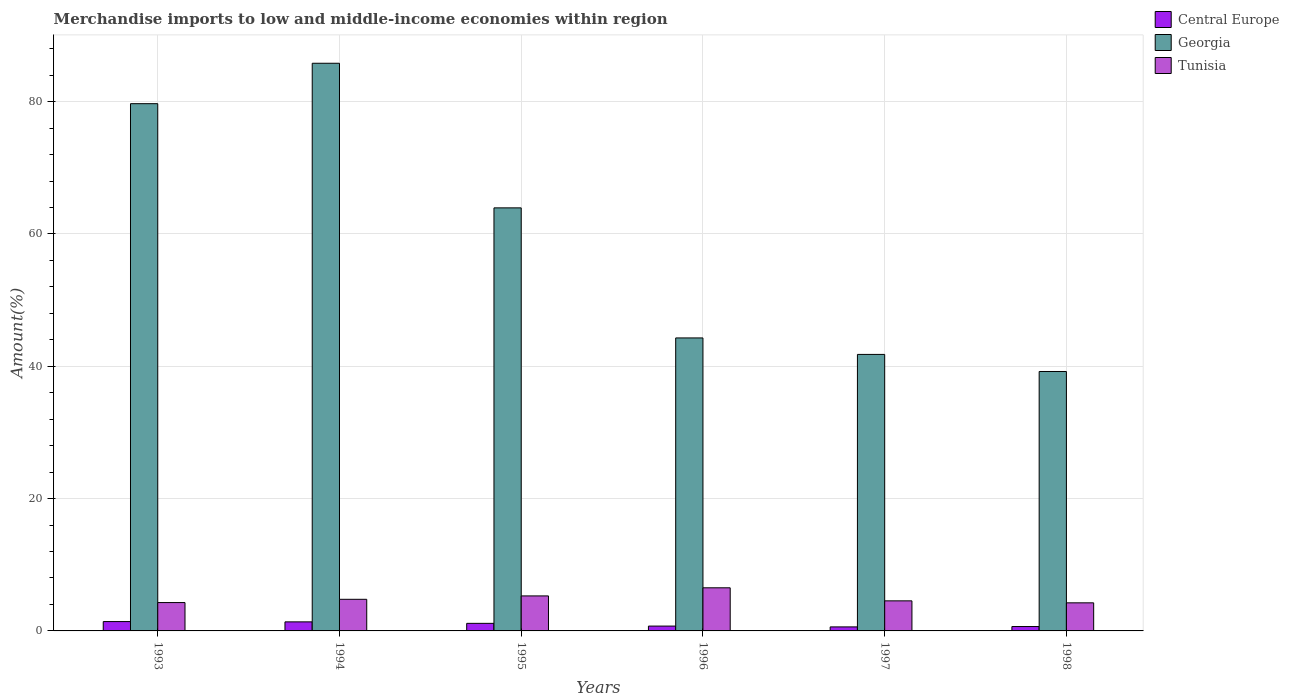Are the number of bars per tick equal to the number of legend labels?
Offer a very short reply. Yes. Are the number of bars on each tick of the X-axis equal?
Provide a succinct answer. Yes. In how many cases, is the number of bars for a given year not equal to the number of legend labels?
Give a very brief answer. 0. What is the percentage of amount earned from merchandise imports in Georgia in 1997?
Offer a very short reply. 41.8. Across all years, what is the maximum percentage of amount earned from merchandise imports in Central Europe?
Make the answer very short. 1.41. Across all years, what is the minimum percentage of amount earned from merchandise imports in Tunisia?
Your answer should be very brief. 4.25. In which year was the percentage of amount earned from merchandise imports in Central Europe minimum?
Keep it short and to the point. 1997. What is the total percentage of amount earned from merchandise imports in Central Europe in the graph?
Keep it short and to the point. 5.92. What is the difference between the percentage of amount earned from merchandise imports in Tunisia in 1996 and that in 1997?
Offer a terse response. 1.97. What is the difference between the percentage of amount earned from merchandise imports in Central Europe in 1994 and the percentage of amount earned from merchandise imports in Tunisia in 1995?
Keep it short and to the point. -3.92. What is the average percentage of amount earned from merchandise imports in Georgia per year?
Offer a terse response. 59.13. In the year 1996, what is the difference between the percentage of amount earned from merchandise imports in Tunisia and percentage of amount earned from merchandise imports in Central Europe?
Provide a short and direct response. 5.79. In how many years, is the percentage of amount earned from merchandise imports in Central Europe greater than 76 %?
Your answer should be very brief. 0. What is the ratio of the percentage of amount earned from merchandise imports in Georgia in 1993 to that in 1998?
Your response must be concise. 2.03. Is the percentage of amount earned from merchandise imports in Central Europe in 1996 less than that in 1997?
Make the answer very short. No. What is the difference between the highest and the second highest percentage of amount earned from merchandise imports in Georgia?
Keep it short and to the point. 6.11. What is the difference between the highest and the lowest percentage of amount earned from merchandise imports in Central Europe?
Offer a terse response. 0.81. In how many years, is the percentage of amount earned from merchandise imports in Tunisia greater than the average percentage of amount earned from merchandise imports in Tunisia taken over all years?
Your answer should be very brief. 2. What does the 2nd bar from the left in 1998 represents?
Provide a short and direct response. Georgia. What does the 2nd bar from the right in 1998 represents?
Offer a terse response. Georgia. How many bars are there?
Your response must be concise. 18. How many years are there in the graph?
Ensure brevity in your answer.  6. Are the values on the major ticks of Y-axis written in scientific E-notation?
Offer a very short reply. No. Does the graph contain any zero values?
Offer a terse response. No. What is the title of the graph?
Your answer should be very brief. Merchandise imports to low and middle-income economies within region. Does "Azerbaijan" appear as one of the legend labels in the graph?
Make the answer very short. No. What is the label or title of the Y-axis?
Offer a very short reply. Amount(%). What is the Amount(%) in Central Europe in 1993?
Offer a terse response. 1.41. What is the Amount(%) of Georgia in 1993?
Your answer should be very brief. 79.7. What is the Amount(%) of Tunisia in 1993?
Offer a terse response. 4.28. What is the Amount(%) of Central Europe in 1994?
Make the answer very short. 1.37. What is the Amount(%) in Georgia in 1994?
Ensure brevity in your answer.  85.81. What is the Amount(%) in Tunisia in 1994?
Provide a short and direct response. 4.78. What is the Amount(%) of Central Europe in 1995?
Give a very brief answer. 1.14. What is the Amount(%) of Georgia in 1995?
Ensure brevity in your answer.  63.95. What is the Amount(%) of Tunisia in 1995?
Make the answer very short. 5.29. What is the Amount(%) in Central Europe in 1996?
Provide a short and direct response. 0.73. What is the Amount(%) of Georgia in 1996?
Offer a terse response. 44.29. What is the Amount(%) of Tunisia in 1996?
Offer a terse response. 6.52. What is the Amount(%) in Central Europe in 1997?
Make the answer very short. 0.61. What is the Amount(%) of Georgia in 1997?
Keep it short and to the point. 41.8. What is the Amount(%) in Tunisia in 1997?
Keep it short and to the point. 4.54. What is the Amount(%) of Central Europe in 1998?
Offer a very short reply. 0.66. What is the Amount(%) in Georgia in 1998?
Give a very brief answer. 39.22. What is the Amount(%) in Tunisia in 1998?
Provide a short and direct response. 4.25. Across all years, what is the maximum Amount(%) in Central Europe?
Provide a succinct answer. 1.41. Across all years, what is the maximum Amount(%) in Georgia?
Ensure brevity in your answer.  85.81. Across all years, what is the maximum Amount(%) in Tunisia?
Your answer should be compact. 6.52. Across all years, what is the minimum Amount(%) in Central Europe?
Offer a terse response. 0.61. Across all years, what is the minimum Amount(%) in Georgia?
Your answer should be very brief. 39.22. Across all years, what is the minimum Amount(%) in Tunisia?
Provide a short and direct response. 4.25. What is the total Amount(%) of Central Europe in the graph?
Keep it short and to the point. 5.92. What is the total Amount(%) in Georgia in the graph?
Give a very brief answer. 354.75. What is the total Amount(%) in Tunisia in the graph?
Your response must be concise. 29.66. What is the difference between the Amount(%) in Central Europe in 1993 and that in 1994?
Offer a very short reply. 0.04. What is the difference between the Amount(%) of Georgia in 1993 and that in 1994?
Provide a succinct answer. -6.11. What is the difference between the Amount(%) in Tunisia in 1993 and that in 1994?
Offer a terse response. -0.49. What is the difference between the Amount(%) of Central Europe in 1993 and that in 1995?
Provide a short and direct response. 0.27. What is the difference between the Amount(%) of Georgia in 1993 and that in 1995?
Offer a very short reply. 15.75. What is the difference between the Amount(%) of Tunisia in 1993 and that in 1995?
Ensure brevity in your answer.  -1.01. What is the difference between the Amount(%) in Central Europe in 1993 and that in 1996?
Your answer should be compact. 0.68. What is the difference between the Amount(%) in Georgia in 1993 and that in 1996?
Make the answer very short. 35.41. What is the difference between the Amount(%) of Tunisia in 1993 and that in 1996?
Make the answer very short. -2.23. What is the difference between the Amount(%) in Central Europe in 1993 and that in 1997?
Provide a succinct answer. 0.81. What is the difference between the Amount(%) in Georgia in 1993 and that in 1997?
Provide a short and direct response. 37.9. What is the difference between the Amount(%) of Tunisia in 1993 and that in 1997?
Give a very brief answer. -0.26. What is the difference between the Amount(%) of Central Europe in 1993 and that in 1998?
Provide a succinct answer. 0.75. What is the difference between the Amount(%) of Georgia in 1993 and that in 1998?
Your answer should be compact. 40.48. What is the difference between the Amount(%) of Tunisia in 1993 and that in 1998?
Ensure brevity in your answer.  0.04. What is the difference between the Amount(%) of Central Europe in 1994 and that in 1995?
Give a very brief answer. 0.22. What is the difference between the Amount(%) in Georgia in 1994 and that in 1995?
Provide a short and direct response. 21.86. What is the difference between the Amount(%) of Tunisia in 1994 and that in 1995?
Your answer should be compact. -0.51. What is the difference between the Amount(%) in Central Europe in 1994 and that in 1996?
Offer a terse response. 0.64. What is the difference between the Amount(%) of Georgia in 1994 and that in 1996?
Ensure brevity in your answer.  41.52. What is the difference between the Amount(%) in Tunisia in 1994 and that in 1996?
Offer a terse response. -1.74. What is the difference between the Amount(%) of Central Europe in 1994 and that in 1997?
Make the answer very short. 0.76. What is the difference between the Amount(%) of Georgia in 1994 and that in 1997?
Offer a very short reply. 44.01. What is the difference between the Amount(%) of Tunisia in 1994 and that in 1997?
Offer a very short reply. 0.23. What is the difference between the Amount(%) of Central Europe in 1994 and that in 1998?
Provide a short and direct response. 0.71. What is the difference between the Amount(%) of Georgia in 1994 and that in 1998?
Offer a very short reply. 46.59. What is the difference between the Amount(%) in Tunisia in 1994 and that in 1998?
Make the answer very short. 0.53. What is the difference between the Amount(%) of Central Europe in 1995 and that in 1996?
Give a very brief answer. 0.41. What is the difference between the Amount(%) of Georgia in 1995 and that in 1996?
Your response must be concise. 19.66. What is the difference between the Amount(%) in Tunisia in 1995 and that in 1996?
Give a very brief answer. -1.23. What is the difference between the Amount(%) in Central Europe in 1995 and that in 1997?
Give a very brief answer. 0.54. What is the difference between the Amount(%) of Georgia in 1995 and that in 1997?
Provide a succinct answer. 22.15. What is the difference between the Amount(%) in Tunisia in 1995 and that in 1997?
Offer a very short reply. 0.75. What is the difference between the Amount(%) in Central Europe in 1995 and that in 1998?
Offer a very short reply. 0.48. What is the difference between the Amount(%) in Georgia in 1995 and that in 1998?
Provide a short and direct response. 24.73. What is the difference between the Amount(%) in Tunisia in 1995 and that in 1998?
Make the answer very short. 1.05. What is the difference between the Amount(%) in Central Europe in 1996 and that in 1997?
Offer a terse response. 0.12. What is the difference between the Amount(%) of Georgia in 1996 and that in 1997?
Offer a terse response. 2.49. What is the difference between the Amount(%) of Tunisia in 1996 and that in 1997?
Give a very brief answer. 1.97. What is the difference between the Amount(%) of Central Europe in 1996 and that in 1998?
Provide a short and direct response. 0.07. What is the difference between the Amount(%) in Georgia in 1996 and that in 1998?
Keep it short and to the point. 5.07. What is the difference between the Amount(%) of Tunisia in 1996 and that in 1998?
Your response must be concise. 2.27. What is the difference between the Amount(%) of Central Europe in 1997 and that in 1998?
Offer a very short reply. -0.05. What is the difference between the Amount(%) of Georgia in 1997 and that in 1998?
Provide a succinct answer. 2.58. What is the difference between the Amount(%) of Tunisia in 1997 and that in 1998?
Give a very brief answer. 0.3. What is the difference between the Amount(%) of Central Europe in 1993 and the Amount(%) of Georgia in 1994?
Make the answer very short. -84.39. What is the difference between the Amount(%) in Central Europe in 1993 and the Amount(%) in Tunisia in 1994?
Offer a terse response. -3.37. What is the difference between the Amount(%) of Georgia in 1993 and the Amount(%) of Tunisia in 1994?
Provide a short and direct response. 74.92. What is the difference between the Amount(%) of Central Europe in 1993 and the Amount(%) of Georgia in 1995?
Offer a very short reply. -62.54. What is the difference between the Amount(%) of Central Europe in 1993 and the Amount(%) of Tunisia in 1995?
Keep it short and to the point. -3.88. What is the difference between the Amount(%) of Georgia in 1993 and the Amount(%) of Tunisia in 1995?
Provide a short and direct response. 74.41. What is the difference between the Amount(%) in Central Europe in 1993 and the Amount(%) in Georgia in 1996?
Give a very brief answer. -42.88. What is the difference between the Amount(%) in Central Europe in 1993 and the Amount(%) in Tunisia in 1996?
Your answer should be compact. -5.11. What is the difference between the Amount(%) of Georgia in 1993 and the Amount(%) of Tunisia in 1996?
Offer a terse response. 73.18. What is the difference between the Amount(%) in Central Europe in 1993 and the Amount(%) in Georgia in 1997?
Keep it short and to the point. -40.38. What is the difference between the Amount(%) of Central Europe in 1993 and the Amount(%) of Tunisia in 1997?
Offer a very short reply. -3.13. What is the difference between the Amount(%) of Georgia in 1993 and the Amount(%) of Tunisia in 1997?
Make the answer very short. 75.15. What is the difference between the Amount(%) of Central Europe in 1993 and the Amount(%) of Georgia in 1998?
Provide a succinct answer. -37.8. What is the difference between the Amount(%) in Central Europe in 1993 and the Amount(%) in Tunisia in 1998?
Offer a terse response. -2.83. What is the difference between the Amount(%) of Georgia in 1993 and the Amount(%) of Tunisia in 1998?
Give a very brief answer. 75.45. What is the difference between the Amount(%) in Central Europe in 1994 and the Amount(%) in Georgia in 1995?
Offer a terse response. -62.58. What is the difference between the Amount(%) of Central Europe in 1994 and the Amount(%) of Tunisia in 1995?
Provide a succinct answer. -3.92. What is the difference between the Amount(%) in Georgia in 1994 and the Amount(%) in Tunisia in 1995?
Provide a succinct answer. 80.52. What is the difference between the Amount(%) of Central Europe in 1994 and the Amount(%) of Georgia in 1996?
Your answer should be compact. -42.92. What is the difference between the Amount(%) in Central Europe in 1994 and the Amount(%) in Tunisia in 1996?
Offer a very short reply. -5.15. What is the difference between the Amount(%) of Georgia in 1994 and the Amount(%) of Tunisia in 1996?
Offer a terse response. 79.29. What is the difference between the Amount(%) of Central Europe in 1994 and the Amount(%) of Georgia in 1997?
Your answer should be compact. -40.43. What is the difference between the Amount(%) in Central Europe in 1994 and the Amount(%) in Tunisia in 1997?
Provide a short and direct response. -3.18. What is the difference between the Amount(%) of Georgia in 1994 and the Amount(%) of Tunisia in 1997?
Offer a very short reply. 81.26. What is the difference between the Amount(%) of Central Europe in 1994 and the Amount(%) of Georgia in 1998?
Your response must be concise. -37.85. What is the difference between the Amount(%) of Central Europe in 1994 and the Amount(%) of Tunisia in 1998?
Provide a succinct answer. -2.88. What is the difference between the Amount(%) of Georgia in 1994 and the Amount(%) of Tunisia in 1998?
Provide a short and direct response. 81.56. What is the difference between the Amount(%) of Central Europe in 1995 and the Amount(%) of Georgia in 1996?
Your answer should be compact. -43.14. What is the difference between the Amount(%) in Central Europe in 1995 and the Amount(%) in Tunisia in 1996?
Your answer should be very brief. -5.37. What is the difference between the Amount(%) in Georgia in 1995 and the Amount(%) in Tunisia in 1996?
Your answer should be compact. 57.43. What is the difference between the Amount(%) of Central Europe in 1995 and the Amount(%) of Georgia in 1997?
Your response must be concise. -40.65. What is the difference between the Amount(%) of Central Europe in 1995 and the Amount(%) of Tunisia in 1997?
Make the answer very short. -3.4. What is the difference between the Amount(%) of Georgia in 1995 and the Amount(%) of Tunisia in 1997?
Provide a short and direct response. 59.41. What is the difference between the Amount(%) of Central Europe in 1995 and the Amount(%) of Georgia in 1998?
Provide a short and direct response. -38.07. What is the difference between the Amount(%) in Central Europe in 1995 and the Amount(%) in Tunisia in 1998?
Offer a very short reply. -3.1. What is the difference between the Amount(%) of Georgia in 1995 and the Amount(%) of Tunisia in 1998?
Provide a succinct answer. 59.7. What is the difference between the Amount(%) of Central Europe in 1996 and the Amount(%) of Georgia in 1997?
Keep it short and to the point. -41.07. What is the difference between the Amount(%) in Central Europe in 1996 and the Amount(%) in Tunisia in 1997?
Provide a short and direct response. -3.81. What is the difference between the Amount(%) in Georgia in 1996 and the Amount(%) in Tunisia in 1997?
Offer a terse response. 39.74. What is the difference between the Amount(%) of Central Europe in 1996 and the Amount(%) of Georgia in 1998?
Provide a short and direct response. -38.49. What is the difference between the Amount(%) in Central Europe in 1996 and the Amount(%) in Tunisia in 1998?
Your answer should be compact. -3.52. What is the difference between the Amount(%) in Georgia in 1996 and the Amount(%) in Tunisia in 1998?
Your answer should be compact. 40.04. What is the difference between the Amount(%) of Central Europe in 1997 and the Amount(%) of Georgia in 1998?
Offer a terse response. -38.61. What is the difference between the Amount(%) in Central Europe in 1997 and the Amount(%) in Tunisia in 1998?
Provide a short and direct response. -3.64. What is the difference between the Amount(%) in Georgia in 1997 and the Amount(%) in Tunisia in 1998?
Give a very brief answer. 37.55. What is the average Amount(%) in Central Europe per year?
Offer a very short reply. 0.99. What is the average Amount(%) in Georgia per year?
Ensure brevity in your answer.  59.13. What is the average Amount(%) in Tunisia per year?
Ensure brevity in your answer.  4.94. In the year 1993, what is the difference between the Amount(%) in Central Europe and Amount(%) in Georgia?
Your answer should be compact. -78.29. In the year 1993, what is the difference between the Amount(%) in Central Europe and Amount(%) in Tunisia?
Offer a very short reply. -2.87. In the year 1993, what is the difference between the Amount(%) in Georgia and Amount(%) in Tunisia?
Ensure brevity in your answer.  75.41. In the year 1994, what is the difference between the Amount(%) of Central Europe and Amount(%) of Georgia?
Provide a succinct answer. -84.44. In the year 1994, what is the difference between the Amount(%) in Central Europe and Amount(%) in Tunisia?
Provide a succinct answer. -3.41. In the year 1994, what is the difference between the Amount(%) of Georgia and Amount(%) of Tunisia?
Your answer should be very brief. 81.03. In the year 1995, what is the difference between the Amount(%) in Central Europe and Amount(%) in Georgia?
Your answer should be compact. -62.81. In the year 1995, what is the difference between the Amount(%) in Central Europe and Amount(%) in Tunisia?
Provide a succinct answer. -4.15. In the year 1995, what is the difference between the Amount(%) in Georgia and Amount(%) in Tunisia?
Make the answer very short. 58.66. In the year 1996, what is the difference between the Amount(%) of Central Europe and Amount(%) of Georgia?
Your response must be concise. -43.56. In the year 1996, what is the difference between the Amount(%) in Central Europe and Amount(%) in Tunisia?
Ensure brevity in your answer.  -5.79. In the year 1996, what is the difference between the Amount(%) in Georgia and Amount(%) in Tunisia?
Make the answer very short. 37.77. In the year 1997, what is the difference between the Amount(%) of Central Europe and Amount(%) of Georgia?
Your response must be concise. -41.19. In the year 1997, what is the difference between the Amount(%) of Central Europe and Amount(%) of Tunisia?
Keep it short and to the point. -3.94. In the year 1997, what is the difference between the Amount(%) in Georgia and Amount(%) in Tunisia?
Provide a succinct answer. 37.25. In the year 1998, what is the difference between the Amount(%) of Central Europe and Amount(%) of Georgia?
Provide a succinct answer. -38.55. In the year 1998, what is the difference between the Amount(%) of Central Europe and Amount(%) of Tunisia?
Ensure brevity in your answer.  -3.58. In the year 1998, what is the difference between the Amount(%) in Georgia and Amount(%) in Tunisia?
Offer a very short reply. 34.97. What is the ratio of the Amount(%) in Central Europe in 1993 to that in 1994?
Provide a succinct answer. 1.03. What is the ratio of the Amount(%) of Georgia in 1993 to that in 1994?
Your answer should be very brief. 0.93. What is the ratio of the Amount(%) in Tunisia in 1993 to that in 1994?
Provide a succinct answer. 0.9. What is the ratio of the Amount(%) in Central Europe in 1993 to that in 1995?
Your response must be concise. 1.24. What is the ratio of the Amount(%) in Georgia in 1993 to that in 1995?
Provide a short and direct response. 1.25. What is the ratio of the Amount(%) of Tunisia in 1993 to that in 1995?
Keep it short and to the point. 0.81. What is the ratio of the Amount(%) of Central Europe in 1993 to that in 1996?
Give a very brief answer. 1.93. What is the ratio of the Amount(%) in Georgia in 1993 to that in 1996?
Make the answer very short. 1.8. What is the ratio of the Amount(%) of Tunisia in 1993 to that in 1996?
Offer a very short reply. 0.66. What is the ratio of the Amount(%) of Central Europe in 1993 to that in 1997?
Your answer should be very brief. 2.33. What is the ratio of the Amount(%) in Georgia in 1993 to that in 1997?
Keep it short and to the point. 1.91. What is the ratio of the Amount(%) of Tunisia in 1993 to that in 1997?
Offer a very short reply. 0.94. What is the ratio of the Amount(%) in Central Europe in 1993 to that in 1998?
Your answer should be compact. 2.13. What is the ratio of the Amount(%) of Georgia in 1993 to that in 1998?
Your answer should be compact. 2.03. What is the ratio of the Amount(%) in Tunisia in 1993 to that in 1998?
Offer a very short reply. 1.01. What is the ratio of the Amount(%) in Central Europe in 1994 to that in 1995?
Provide a short and direct response. 1.2. What is the ratio of the Amount(%) in Georgia in 1994 to that in 1995?
Offer a very short reply. 1.34. What is the ratio of the Amount(%) in Tunisia in 1994 to that in 1995?
Give a very brief answer. 0.9. What is the ratio of the Amount(%) of Central Europe in 1994 to that in 1996?
Provide a short and direct response. 1.87. What is the ratio of the Amount(%) of Georgia in 1994 to that in 1996?
Ensure brevity in your answer.  1.94. What is the ratio of the Amount(%) of Tunisia in 1994 to that in 1996?
Your answer should be very brief. 0.73. What is the ratio of the Amount(%) of Central Europe in 1994 to that in 1997?
Keep it short and to the point. 2.25. What is the ratio of the Amount(%) of Georgia in 1994 to that in 1997?
Your answer should be very brief. 2.05. What is the ratio of the Amount(%) in Tunisia in 1994 to that in 1997?
Keep it short and to the point. 1.05. What is the ratio of the Amount(%) of Central Europe in 1994 to that in 1998?
Offer a very short reply. 2.07. What is the ratio of the Amount(%) in Georgia in 1994 to that in 1998?
Provide a short and direct response. 2.19. What is the ratio of the Amount(%) in Tunisia in 1994 to that in 1998?
Give a very brief answer. 1.13. What is the ratio of the Amount(%) of Central Europe in 1995 to that in 1996?
Your answer should be very brief. 1.57. What is the ratio of the Amount(%) in Georgia in 1995 to that in 1996?
Your response must be concise. 1.44. What is the ratio of the Amount(%) of Tunisia in 1995 to that in 1996?
Your answer should be compact. 0.81. What is the ratio of the Amount(%) of Central Europe in 1995 to that in 1997?
Your answer should be very brief. 1.88. What is the ratio of the Amount(%) in Georgia in 1995 to that in 1997?
Offer a terse response. 1.53. What is the ratio of the Amount(%) of Tunisia in 1995 to that in 1997?
Your response must be concise. 1.16. What is the ratio of the Amount(%) of Central Europe in 1995 to that in 1998?
Your response must be concise. 1.73. What is the ratio of the Amount(%) of Georgia in 1995 to that in 1998?
Offer a very short reply. 1.63. What is the ratio of the Amount(%) in Tunisia in 1995 to that in 1998?
Provide a short and direct response. 1.25. What is the ratio of the Amount(%) in Central Europe in 1996 to that in 1997?
Give a very brief answer. 1.2. What is the ratio of the Amount(%) in Georgia in 1996 to that in 1997?
Ensure brevity in your answer.  1.06. What is the ratio of the Amount(%) in Tunisia in 1996 to that in 1997?
Your answer should be very brief. 1.43. What is the ratio of the Amount(%) in Central Europe in 1996 to that in 1998?
Your answer should be very brief. 1.1. What is the ratio of the Amount(%) in Georgia in 1996 to that in 1998?
Provide a succinct answer. 1.13. What is the ratio of the Amount(%) of Tunisia in 1996 to that in 1998?
Give a very brief answer. 1.54. What is the ratio of the Amount(%) in Central Europe in 1997 to that in 1998?
Ensure brevity in your answer.  0.92. What is the ratio of the Amount(%) of Georgia in 1997 to that in 1998?
Keep it short and to the point. 1.07. What is the ratio of the Amount(%) in Tunisia in 1997 to that in 1998?
Keep it short and to the point. 1.07. What is the difference between the highest and the second highest Amount(%) of Central Europe?
Your answer should be compact. 0.04. What is the difference between the highest and the second highest Amount(%) of Georgia?
Offer a terse response. 6.11. What is the difference between the highest and the second highest Amount(%) of Tunisia?
Offer a terse response. 1.23. What is the difference between the highest and the lowest Amount(%) of Central Europe?
Your answer should be very brief. 0.81. What is the difference between the highest and the lowest Amount(%) of Georgia?
Give a very brief answer. 46.59. What is the difference between the highest and the lowest Amount(%) in Tunisia?
Keep it short and to the point. 2.27. 